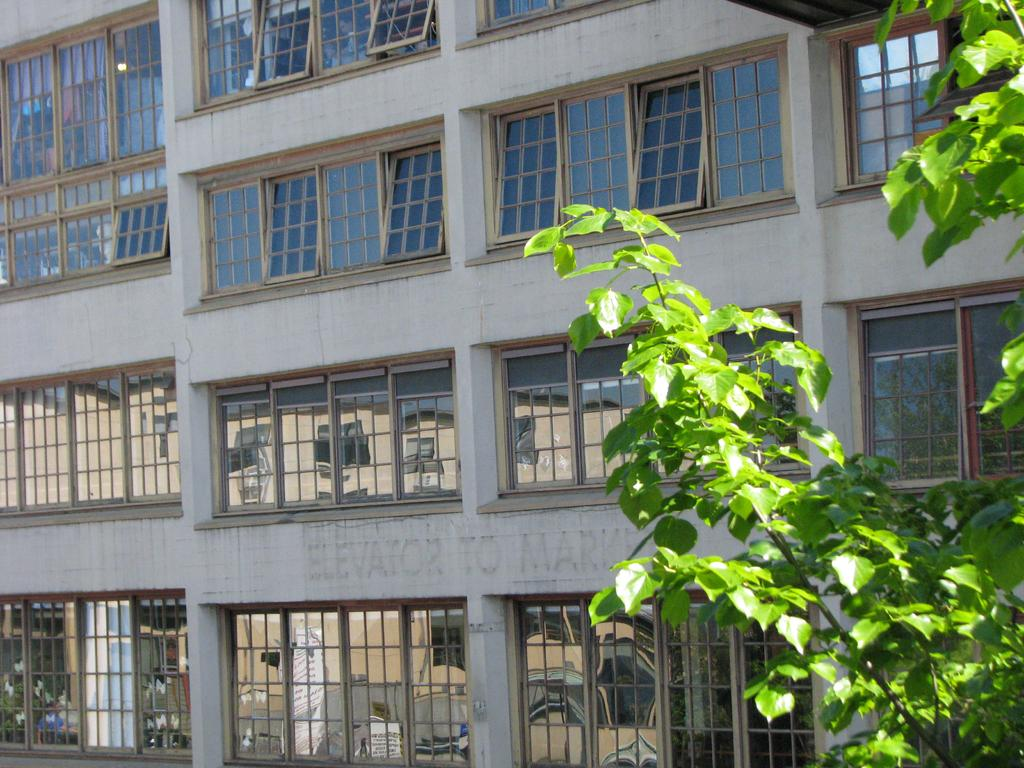What type of structure is shown in the image? There is a building with many windows in the image. What material is used for the windows and other elements of the building? The building has glass elements. Can you identify any natural elements in the image? Yes, there is a part of a plant visible in the image. What type of bell can be heard ringing in the image? There is no bell present in the image, and therefore no sound can be heard. Is there a sidewalk visible in the image? The provided facts do not mention a sidewalk, so we cannot determine its presence from the image. 